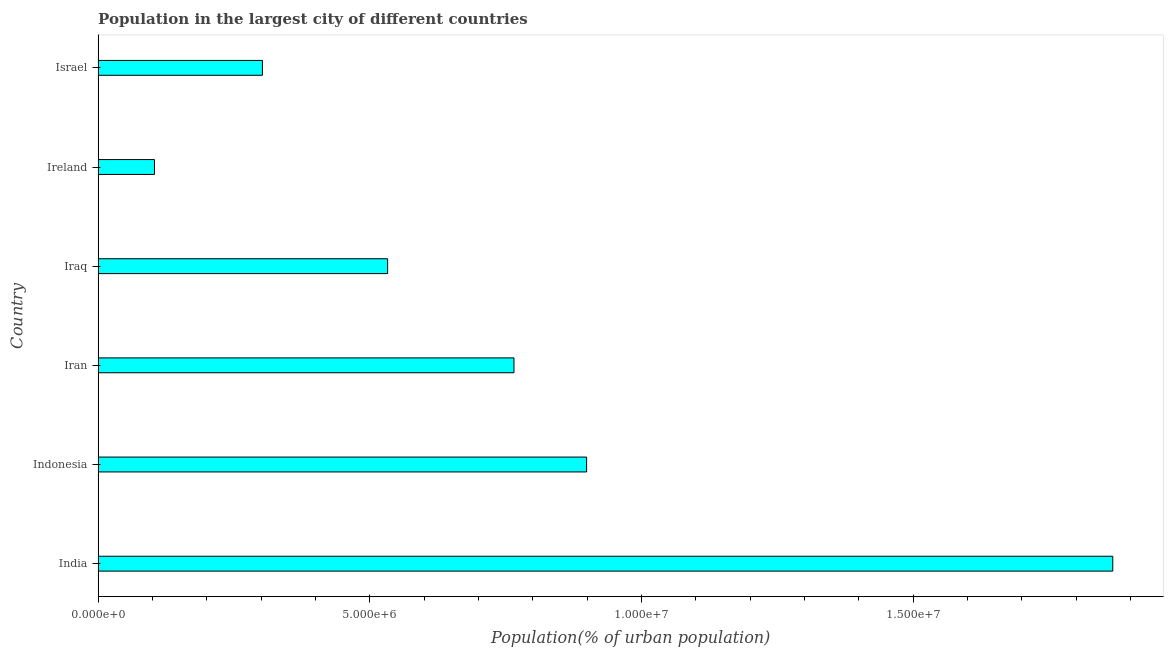What is the title of the graph?
Make the answer very short. Population in the largest city of different countries. What is the label or title of the X-axis?
Provide a succinct answer. Population(% of urban population). What is the population in largest city in Ireland?
Your answer should be compact. 1.04e+06. Across all countries, what is the maximum population in largest city?
Your answer should be compact. 1.87e+07. Across all countries, what is the minimum population in largest city?
Provide a short and direct response. 1.04e+06. In which country was the population in largest city maximum?
Provide a succinct answer. India. In which country was the population in largest city minimum?
Offer a terse response. Ireland. What is the sum of the population in largest city?
Offer a very short reply. 4.47e+07. What is the difference between the population in largest city in Iran and Iraq?
Provide a succinct answer. 2.32e+06. What is the average population in largest city per country?
Keep it short and to the point. 7.45e+06. What is the median population in largest city?
Your response must be concise. 6.49e+06. What is the ratio of the population in largest city in Iran to that in Ireland?
Offer a very short reply. 7.38. Is the population in largest city in India less than that in Iraq?
Give a very brief answer. No. Is the difference between the population in largest city in Indonesia and Iraq greater than the difference between any two countries?
Ensure brevity in your answer.  No. What is the difference between the highest and the second highest population in largest city?
Your answer should be compact. 9.68e+06. Is the sum of the population in largest city in Ireland and Israel greater than the maximum population in largest city across all countries?
Give a very brief answer. No. What is the difference between the highest and the lowest population in largest city?
Provide a succinct answer. 1.76e+07. Are all the bars in the graph horizontal?
Offer a terse response. Yes. How many countries are there in the graph?
Ensure brevity in your answer.  6. Are the values on the major ticks of X-axis written in scientific E-notation?
Provide a succinct answer. Yes. What is the Population(% of urban population) in India?
Your response must be concise. 1.87e+07. What is the Population(% of urban population) in Indonesia?
Provide a short and direct response. 8.99e+06. What is the Population(% of urban population) of Iran?
Offer a terse response. 7.65e+06. What is the Population(% of urban population) in Iraq?
Keep it short and to the point. 5.33e+06. What is the Population(% of urban population) of Ireland?
Offer a very short reply. 1.04e+06. What is the Population(% of urban population) of Israel?
Ensure brevity in your answer.  3.02e+06. What is the difference between the Population(% of urban population) in India and Indonesia?
Give a very brief answer. 9.68e+06. What is the difference between the Population(% of urban population) in India and Iran?
Provide a short and direct response. 1.10e+07. What is the difference between the Population(% of urban population) in India and Iraq?
Give a very brief answer. 1.33e+07. What is the difference between the Population(% of urban population) in India and Ireland?
Offer a terse response. 1.76e+07. What is the difference between the Population(% of urban population) in India and Israel?
Offer a terse response. 1.56e+07. What is the difference between the Population(% of urban population) in Indonesia and Iran?
Provide a short and direct response. 1.34e+06. What is the difference between the Population(% of urban population) in Indonesia and Iraq?
Offer a terse response. 3.66e+06. What is the difference between the Population(% of urban population) in Indonesia and Ireland?
Offer a terse response. 7.95e+06. What is the difference between the Population(% of urban population) in Indonesia and Israel?
Keep it short and to the point. 5.96e+06. What is the difference between the Population(% of urban population) in Iran and Iraq?
Your answer should be very brief. 2.32e+06. What is the difference between the Population(% of urban population) in Iran and Ireland?
Provide a short and direct response. 6.61e+06. What is the difference between the Population(% of urban population) in Iran and Israel?
Provide a short and direct response. 4.63e+06. What is the difference between the Population(% of urban population) in Iraq and Ireland?
Your response must be concise. 4.29e+06. What is the difference between the Population(% of urban population) in Iraq and Israel?
Your response must be concise. 2.30e+06. What is the difference between the Population(% of urban population) in Ireland and Israel?
Provide a short and direct response. -1.99e+06. What is the ratio of the Population(% of urban population) in India to that in Indonesia?
Make the answer very short. 2.08. What is the ratio of the Population(% of urban population) in India to that in Iran?
Offer a very short reply. 2.44. What is the ratio of the Population(% of urban population) in India to that in Iraq?
Make the answer very short. 3.5. What is the ratio of the Population(% of urban population) in India to that in Ireland?
Your response must be concise. 18. What is the ratio of the Population(% of urban population) in India to that in Israel?
Your response must be concise. 6.17. What is the ratio of the Population(% of urban population) in Indonesia to that in Iran?
Provide a short and direct response. 1.18. What is the ratio of the Population(% of urban population) in Indonesia to that in Iraq?
Your response must be concise. 1.69. What is the ratio of the Population(% of urban population) in Indonesia to that in Ireland?
Keep it short and to the point. 8.67. What is the ratio of the Population(% of urban population) in Indonesia to that in Israel?
Give a very brief answer. 2.97. What is the ratio of the Population(% of urban population) in Iran to that in Iraq?
Offer a very short reply. 1.44. What is the ratio of the Population(% of urban population) in Iran to that in Ireland?
Your answer should be very brief. 7.38. What is the ratio of the Population(% of urban population) in Iran to that in Israel?
Provide a succinct answer. 2.53. What is the ratio of the Population(% of urban population) in Iraq to that in Ireland?
Give a very brief answer. 5.14. What is the ratio of the Population(% of urban population) in Iraq to that in Israel?
Provide a succinct answer. 1.76. What is the ratio of the Population(% of urban population) in Ireland to that in Israel?
Your answer should be compact. 0.34. 